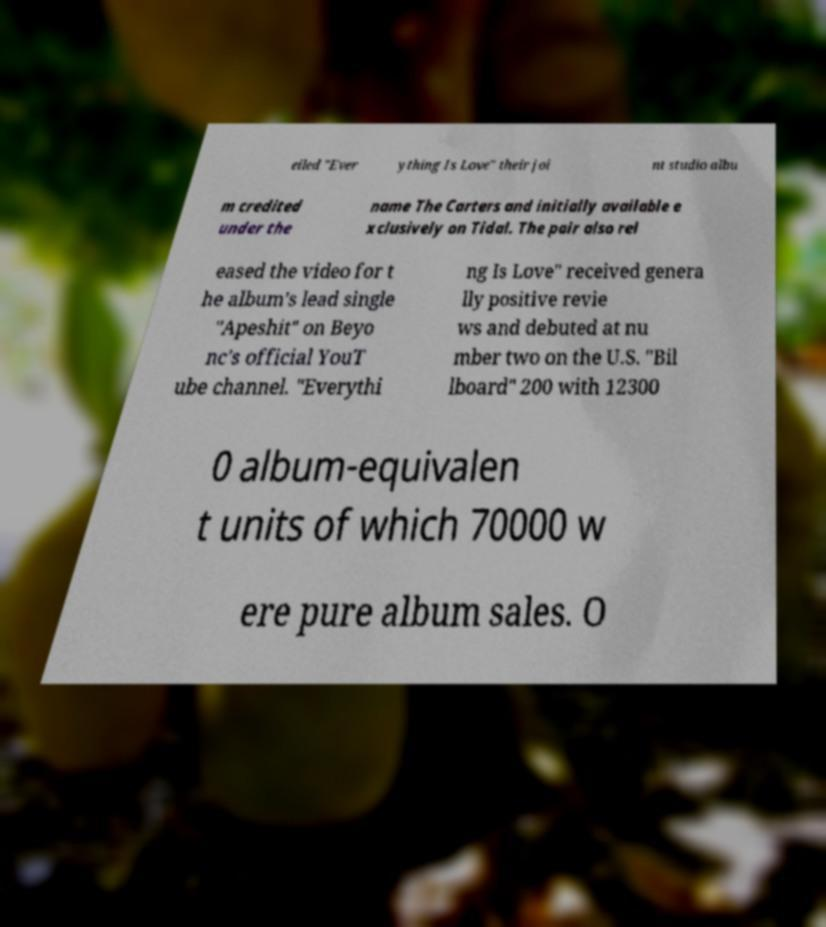Could you assist in decoding the text presented in this image and type it out clearly? eiled "Ever ything Is Love" their joi nt studio albu m credited under the name The Carters and initially available e xclusively on Tidal. The pair also rel eased the video for t he album's lead single "Apeshit" on Beyo nc's official YouT ube channel. "Everythi ng Is Love" received genera lly positive revie ws and debuted at nu mber two on the U.S. "Bil lboard" 200 with 12300 0 album-equivalen t units of which 70000 w ere pure album sales. O 